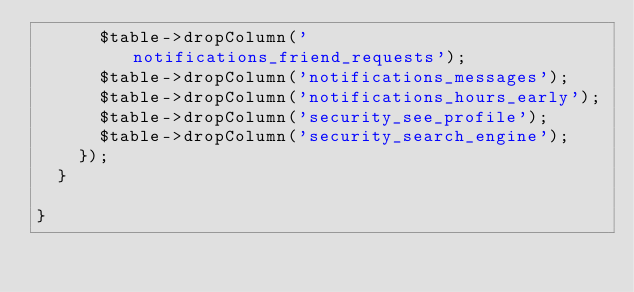<code> <loc_0><loc_0><loc_500><loc_500><_PHP_>			$table->dropColumn('notifications_friend_requests');
			$table->dropColumn('notifications_messages');
			$table->dropColumn('notifications_hours_early');
			$table->dropColumn('security_see_profile');
			$table->dropColumn('security_search_engine');
		});
	}

}
</code> 